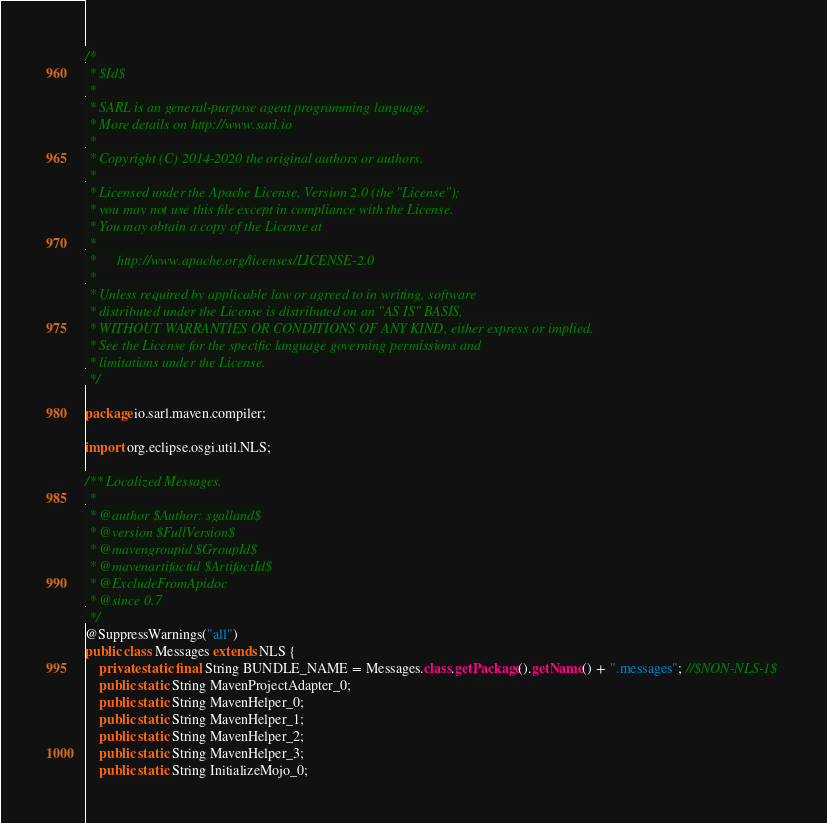Convert code to text. <code><loc_0><loc_0><loc_500><loc_500><_Java_>/*
 * $Id$
 *
 * SARL is an general-purpose agent programming language.
 * More details on http://www.sarl.io
 *
 * Copyright (C) 2014-2020 the original authors or authors.
 *
 * Licensed under the Apache License, Version 2.0 (the "License");
 * you may not use this file except in compliance with the License.
 * You may obtain a copy of the License at
 *
 *      http://www.apache.org/licenses/LICENSE-2.0
 *
 * Unless required by applicable law or agreed to in writing, software
 * distributed under the License is distributed on an "AS IS" BASIS,
 * WITHOUT WARRANTIES OR CONDITIONS OF ANY KIND, either express or implied.
 * See the License for the specific language governing permissions and
 * limitations under the License.
 */

package io.sarl.maven.compiler;

import org.eclipse.osgi.util.NLS;

/** Localized Messages.
 *
 * @author $Author: sgalland$
 * @version $FullVersion$
 * @mavengroupid $GroupId$
 * @mavenartifactid $ArtifactId$
 * @ExcludeFromApidoc
 * @since 0.7
 */
@SuppressWarnings("all")
public class Messages extends NLS {
	private static final String BUNDLE_NAME = Messages.class.getPackage().getName() + ".messages"; //$NON-NLS-1$
	public static String MavenProjectAdapter_0;
	public static String MavenHelper_0;
	public static String MavenHelper_1;
	public static String MavenHelper_2;
	public static String MavenHelper_3;
	public static String InitializeMojo_0;</code> 